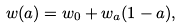<formula> <loc_0><loc_0><loc_500><loc_500>w ( a ) = w _ { 0 } + w _ { a } ( 1 - a ) ,</formula> 